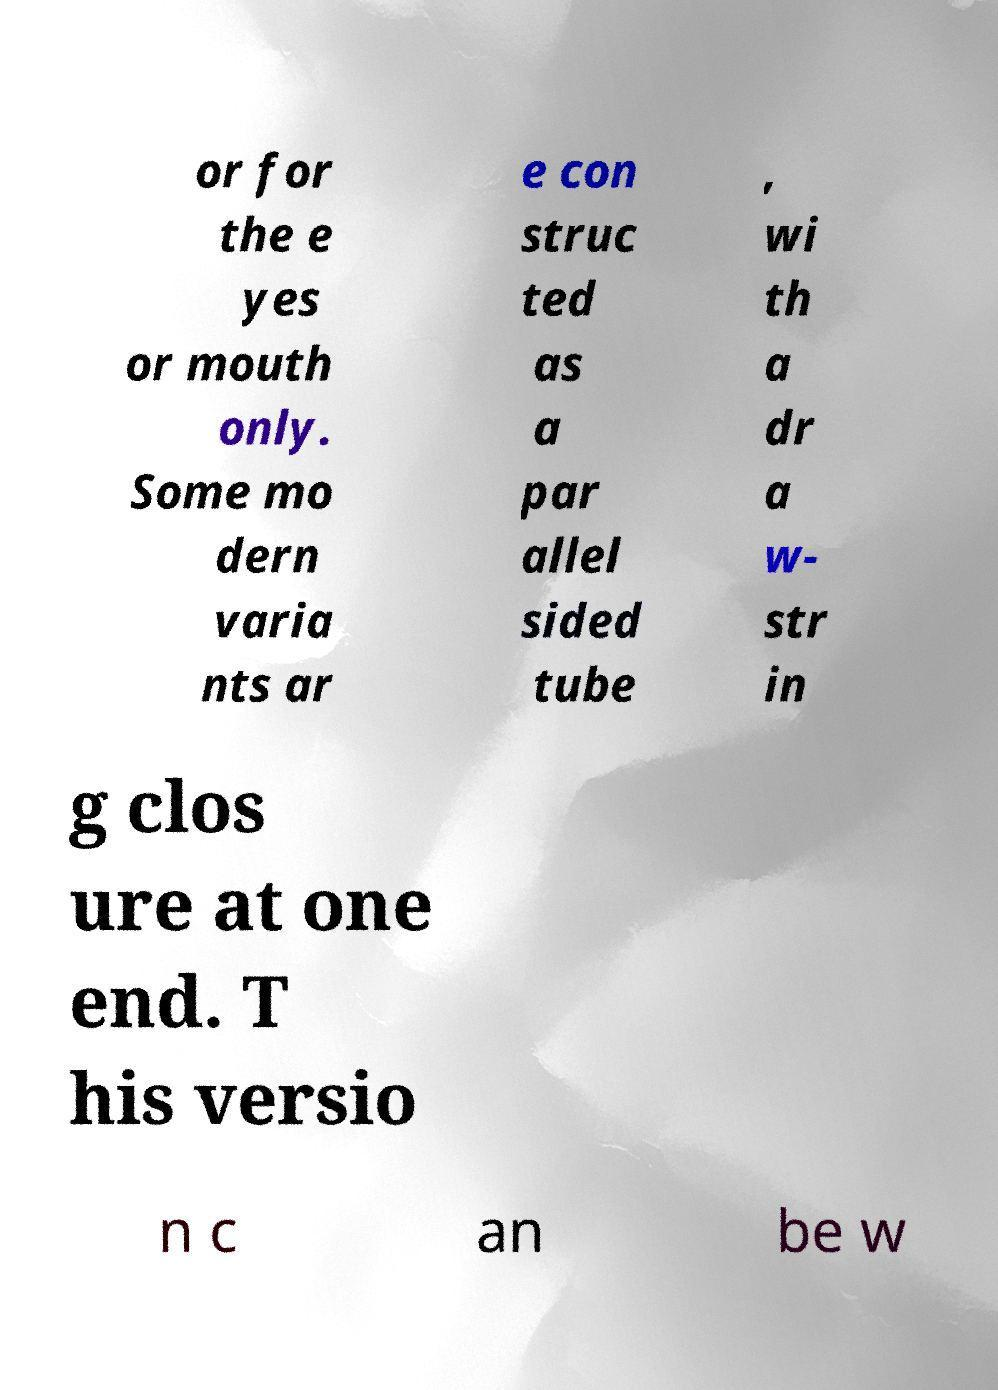I need the written content from this picture converted into text. Can you do that? or for the e yes or mouth only. Some mo dern varia nts ar e con struc ted as a par allel sided tube , wi th a dr a w- str in g clos ure at one end. T his versio n c an be w 